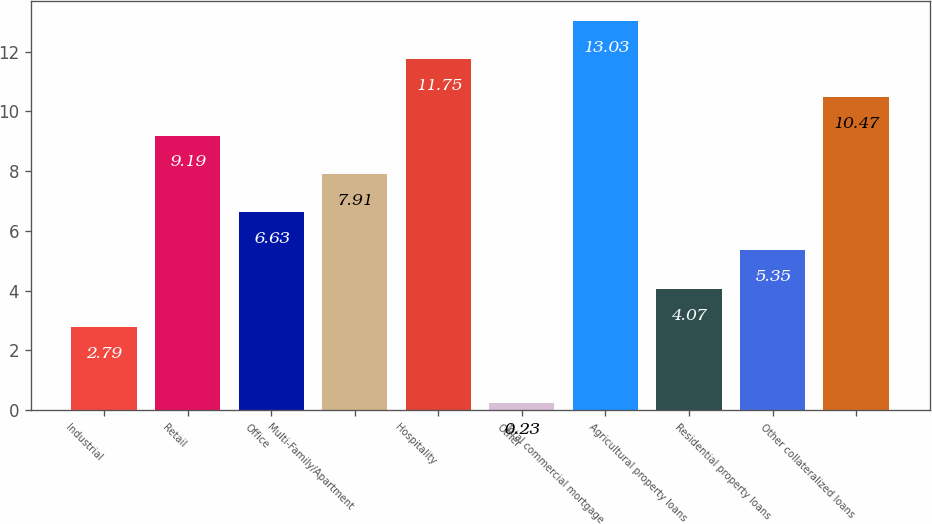Convert chart to OTSL. <chart><loc_0><loc_0><loc_500><loc_500><bar_chart><fcel>Industrial<fcel>Retail<fcel>Office<fcel>Multi-Family/Apartment<fcel>Hospitality<fcel>Other<fcel>Total commercial mortgage<fcel>Agricultural property loans<fcel>Residential property loans<fcel>Other collateralized loans<nl><fcel>2.79<fcel>9.19<fcel>6.63<fcel>7.91<fcel>11.75<fcel>0.23<fcel>13.03<fcel>4.07<fcel>5.35<fcel>10.47<nl></chart> 